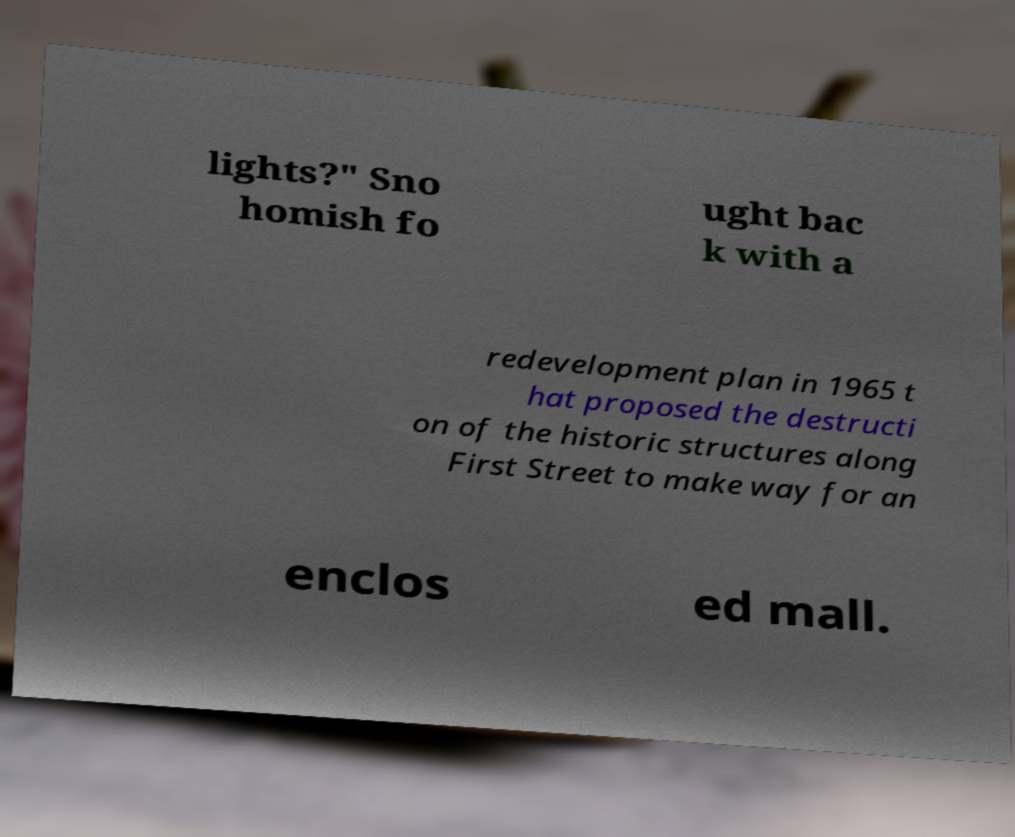Can you accurately transcribe the text from the provided image for me? lights?" Sno homish fo ught bac k with a redevelopment plan in 1965 t hat proposed the destructi on of the historic structures along First Street to make way for an enclos ed mall. 